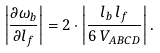<formula> <loc_0><loc_0><loc_500><loc_500>\left | \frac { \partial \omega _ { b } } { \partial l _ { f } } \right | = 2 \cdot \left | \frac { l _ { b } \, l _ { f } } { 6 \, V _ { A B C D } } \right | .</formula> 